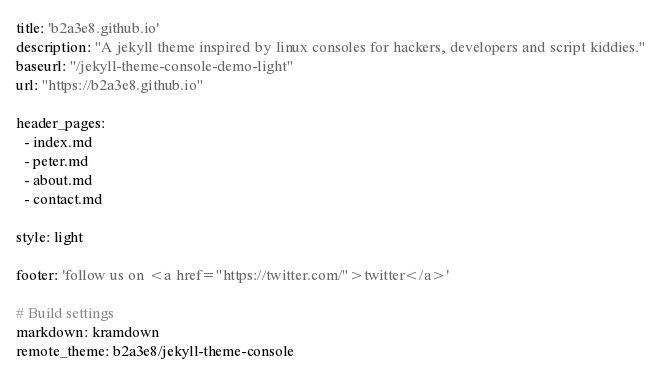<code> <loc_0><loc_0><loc_500><loc_500><_YAML_>title: 'b2a3e8.github.io'
description: "A jekyll theme inspired by linux consoles for hackers, developers and script kiddies."
baseurl: "/jekyll-theme-console-demo-light"
url: "https://b2a3e8.github.io"

header_pages:
  - index.md
  - peter.md
  - about.md
  - contact.md

style: light 

footer: 'follow us on <a href="https://twitter.com/">twitter</a>'

# Build settings
markdown: kramdown
remote_theme: b2a3e8/jekyll-theme-console
</code> 